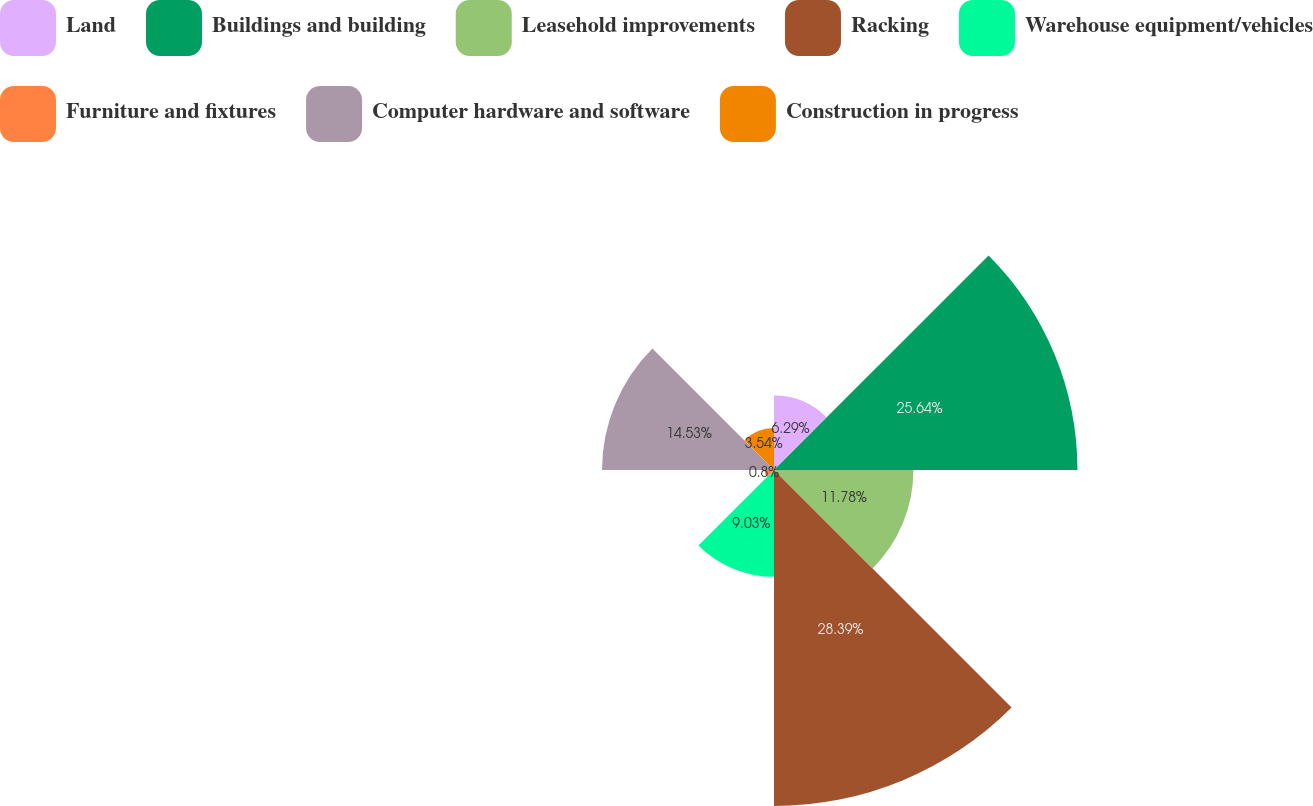<chart> <loc_0><loc_0><loc_500><loc_500><pie_chart><fcel>Land<fcel>Buildings and building<fcel>Leasehold improvements<fcel>Racking<fcel>Warehouse equipment/vehicles<fcel>Furniture and fixtures<fcel>Computer hardware and software<fcel>Construction in progress<nl><fcel>6.29%<fcel>25.64%<fcel>11.78%<fcel>28.39%<fcel>9.03%<fcel>0.8%<fcel>14.53%<fcel>3.54%<nl></chart> 